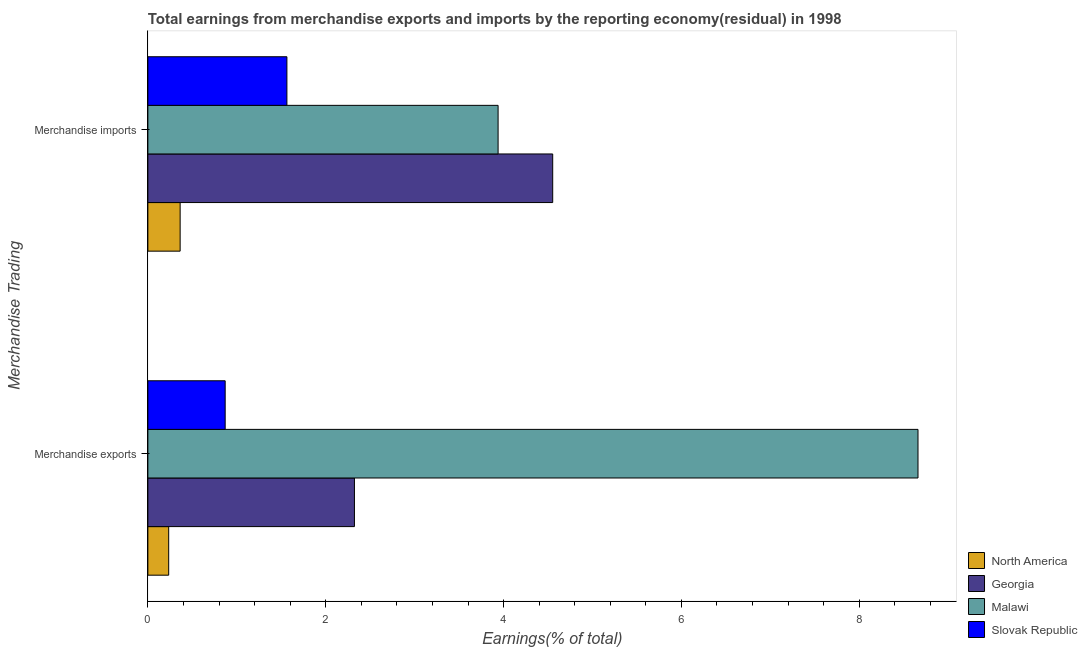Are the number of bars per tick equal to the number of legend labels?
Make the answer very short. Yes. Are the number of bars on each tick of the Y-axis equal?
Your answer should be very brief. Yes. How many bars are there on the 2nd tick from the top?
Your answer should be very brief. 4. What is the label of the 1st group of bars from the top?
Your answer should be very brief. Merchandise imports. What is the earnings from merchandise exports in Georgia?
Ensure brevity in your answer.  2.32. Across all countries, what is the maximum earnings from merchandise imports?
Keep it short and to the point. 4.55. Across all countries, what is the minimum earnings from merchandise imports?
Offer a very short reply. 0.36. In which country was the earnings from merchandise imports maximum?
Offer a terse response. Georgia. What is the total earnings from merchandise imports in the graph?
Make the answer very short. 10.42. What is the difference between the earnings from merchandise exports in Malawi and that in Slovak Republic?
Ensure brevity in your answer.  7.79. What is the difference between the earnings from merchandise imports in Malawi and the earnings from merchandise exports in Georgia?
Give a very brief answer. 1.62. What is the average earnings from merchandise imports per country?
Make the answer very short. 2.6. What is the difference between the earnings from merchandise exports and earnings from merchandise imports in Slovak Republic?
Offer a terse response. -0.69. In how many countries, is the earnings from merchandise imports greater than 7.2 %?
Keep it short and to the point. 0. What is the ratio of the earnings from merchandise exports in North America to that in Slovak Republic?
Keep it short and to the point. 0.27. Is the earnings from merchandise exports in North America less than that in Georgia?
Your answer should be compact. Yes. What does the 4th bar from the bottom in Merchandise exports represents?
Provide a short and direct response. Slovak Republic. How many bars are there?
Keep it short and to the point. 8. Are all the bars in the graph horizontal?
Your response must be concise. Yes. Does the graph contain grids?
Offer a very short reply. No. Where does the legend appear in the graph?
Ensure brevity in your answer.  Bottom right. What is the title of the graph?
Give a very brief answer. Total earnings from merchandise exports and imports by the reporting economy(residual) in 1998. Does "Uganda" appear as one of the legend labels in the graph?
Keep it short and to the point. No. What is the label or title of the X-axis?
Make the answer very short. Earnings(% of total). What is the label or title of the Y-axis?
Offer a very short reply. Merchandise Trading. What is the Earnings(% of total) in North America in Merchandise exports?
Give a very brief answer. 0.23. What is the Earnings(% of total) in Georgia in Merchandise exports?
Make the answer very short. 2.32. What is the Earnings(% of total) in Malawi in Merchandise exports?
Your response must be concise. 8.66. What is the Earnings(% of total) in Slovak Republic in Merchandise exports?
Provide a short and direct response. 0.87. What is the Earnings(% of total) of North America in Merchandise imports?
Your answer should be compact. 0.36. What is the Earnings(% of total) of Georgia in Merchandise imports?
Keep it short and to the point. 4.55. What is the Earnings(% of total) of Malawi in Merchandise imports?
Your response must be concise. 3.94. What is the Earnings(% of total) of Slovak Republic in Merchandise imports?
Offer a terse response. 1.56. Across all Merchandise Trading, what is the maximum Earnings(% of total) in North America?
Provide a short and direct response. 0.36. Across all Merchandise Trading, what is the maximum Earnings(% of total) of Georgia?
Give a very brief answer. 4.55. Across all Merchandise Trading, what is the maximum Earnings(% of total) in Malawi?
Offer a terse response. 8.66. Across all Merchandise Trading, what is the maximum Earnings(% of total) in Slovak Republic?
Provide a short and direct response. 1.56. Across all Merchandise Trading, what is the minimum Earnings(% of total) in North America?
Your response must be concise. 0.23. Across all Merchandise Trading, what is the minimum Earnings(% of total) in Georgia?
Offer a very short reply. 2.32. Across all Merchandise Trading, what is the minimum Earnings(% of total) of Malawi?
Ensure brevity in your answer.  3.94. Across all Merchandise Trading, what is the minimum Earnings(% of total) of Slovak Republic?
Your answer should be compact. 0.87. What is the total Earnings(% of total) of North America in the graph?
Offer a terse response. 0.6. What is the total Earnings(% of total) in Georgia in the graph?
Your response must be concise. 6.88. What is the total Earnings(% of total) of Malawi in the graph?
Your answer should be very brief. 12.6. What is the total Earnings(% of total) of Slovak Republic in the graph?
Offer a terse response. 2.43. What is the difference between the Earnings(% of total) in North America in Merchandise exports and that in Merchandise imports?
Your answer should be compact. -0.13. What is the difference between the Earnings(% of total) of Georgia in Merchandise exports and that in Merchandise imports?
Provide a succinct answer. -2.23. What is the difference between the Earnings(% of total) in Malawi in Merchandise exports and that in Merchandise imports?
Keep it short and to the point. 4.72. What is the difference between the Earnings(% of total) of Slovak Republic in Merchandise exports and that in Merchandise imports?
Your answer should be very brief. -0.69. What is the difference between the Earnings(% of total) in North America in Merchandise exports and the Earnings(% of total) in Georgia in Merchandise imports?
Offer a terse response. -4.32. What is the difference between the Earnings(% of total) of North America in Merchandise exports and the Earnings(% of total) of Malawi in Merchandise imports?
Your answer should be very brief. -3.7. What is the difference between the Earnings(% of total) of North America in Merchandise exports and the Earnings(% of total) of Slovak Republic in Merchandise imports?
Your response must be concise. -1.33. What is the difference between the Earnings(% of total) in Georgia in Merchandise exports and the Earnings(% of total) in Malawi in Merchandise imports?
Your response must be concise. -1.62. What is the difference between the Earnings(% of total) in Georgia in Merchandise exports and the Earnings(% of total) in Slovak Republic in Merchandise imports?
Provide a succinct answer. 0.76. What is the difference between the Earnings(% of total) of Malawi in Merchandise exports and the Earnings(% of total) of Slovak Republic in Merchandise imports?
Make the answer very short. 7.1. What is the average Earnings(% of total) of North America per Merchandise Trading?
Offer a very short reply. 0.3. What is the average Earnings(% of total) of Georgia per Merchandise Trading?
Your response must be concise. 3.44. What is the average Earnings(% of total) in Malawi per Merchandise Trading?
Make the answer very short. 6.3. What is the average Earnings(% of total) of Slovak Republic per Merchandise Trading?
Provide a short and direct response. 1.22. What is the difference between the Earnings(% of total) of North America and Earnings(% of total) of Georgia in Merchandise exports?
Keep it short and to the point. -2.09. What is the difference between the Earnings(% of total) of North America and Earnings(% of total) of Malawi in Merchandise exports?
Your response must be concise. -8.43. What is the difference between the Earnings(% of total) of North America and Earnings(% of total) of Slovak Republic in Merchandise exports?
Offer a very short reply. -0.64. What is the difference between the Earnings(% of total) of Georgia and Earnings(% of total) of Malawi in Merchandise exports?
Provide a short and direct response. -6.34. What is the difference between the Earnings(% of total) of Georgia and Earnings(% of total) of Slovak Republic in Merchandise exports?
Give a very brief answer. 1.45. What is the difference between the Earnings(% of total) of Malawi and Earnings(% of total) of Slovak Republic in Merchandise exports?
Offer a terse response. 7.79. What is the difference between the Earnings(% of total) of North America and Earnings(% of total) of Georgia in Merchandise imports?
Make the answer very short. -4.19. What is the difference between the Earnings(% of total) of North America and Earnings(% of total) of Malawi in Merchandise imports?
Provide a succinct answer. -3.58. What is the difference between the Earnings(% of total) of North America and Earnings(% of total) of Slovak Republic in Merchandise imports?
Offer a terse response. -1.2. What is the difference between the Earnings(% of total) of Georgia and Earnings(% of total) of Malawi in Merchandise imports?
Ensure brevity in your answer.  0.61. What is the difference between the Earnings(% of total) of Georgia and Earnings(% of total) of Slovak Republic in Merchandise imports?
Your response must be concise. 2.99. What is the difference between the Earnings(% of total) of Malawi and Earnings(% of total) of Slovak Republic in Merchandise imports?
Provide a short and direct response. 2.38. What is the ratio of the Earnings(% of total) in North America in Merchandise exports to that in Merchandise imports?
Provide a succinct answer. 0.65. What is the ratio of the Earnings(% of total) in Georgia in Merchandise exports to that in Merchandise imports?
Ensure brevity in your answer.  0.51. What is the ratio of the Earnings(% of total) of Malawi in Merchandise exports to that in Merchandise imports?
Provide a succinct answer. 2.2. What is the ratio of the Earnings(% of total) of Slovak Republic in Merchandise exports to that in Merchandise imports?
Keep it short and to the point. 0.56. What is the difference between the highest and the second highest Earnings(% of total) in North America?
Provide a short and direct response. 0.13. What is the difference between the highest and the second highest Earnings(% of total) in Georgia?
Offer a very short reply. 2.23. What is the difference between the highest and the second highest Earnings(% of total) in Malawi?
Offer a very short reply. 4.72. What is the difference between the highest and the second highest Earnings(% of total) in Slovak Republic?
Offer a terse response. 0.69. What is the difference between the highest and the lowest Earnings(% of total) in North America?
Provide a short and direct response. 0.13. What is the difference between the highest and the lowest Earnings(% of total) of Georgia?
Make the answer very short. 2.23. What is the difference between the highest and the lowest Earnings(% of total) in Malawi?
Make the answer very short. 4.72. What is the difference between the highest and the lowest Earnings(% of total) of Slovak Republic?
Provide a short and direct response. 0.69. 